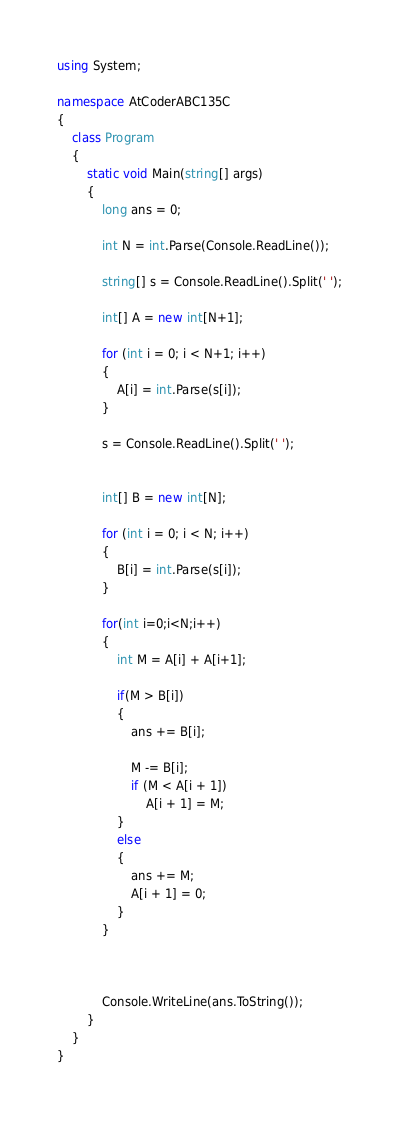<code> <loc_0><loc_0><loc_500><loc_500><_C#_>using System;

namespace AtCoderABC135C
{
    class Program
    {
        static void Main(string[] args)
        {
            long ans = 0;

            int N = int.Parse(Console.ReadLine());

            string[] s = Console.ReadLine().Split(' ');

            int[] A = new int[N+1];

            for (int i = 0; i < N+1; i++)
            {
                A[i] = int.Parse(s[i]);
            }

            s = Console.ReadLine().Split(' ');


            int[] B = new int[N];

            for (int i = 0; i < N; i++)
            {
                B[i] = int.Parse(s[i]);
            }

            for(int i=0;i<N;i++)
            {
                int M = A[i] + A[i+1];

                if(M > B[i])
                {
                    ans += B[i];

                    M -= B[i];
                    if (M < A[i + 1])
                        A[i + 1] = M;
                }
                else
                {
                    ans += M;
                    A[i + 1] = 0;
                }
            }



            Console.WriteLine(ans.ToString());
        }
    }
}
</code> 